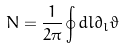Convert formula to latex. <formula><loc_0><loc_0><loc_500><loc_500>N = \frac { 1 } { 2 \pi } \oint d l \partial _ { l } \vartheta</formula> 